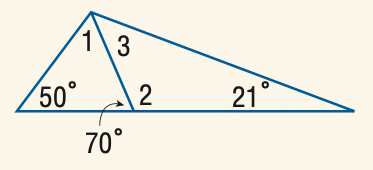Answer the mathemtical geometry problem and directly provide the correct option letter.
Question: Find the measure of \angle 2.
Choices: A: 110 B: 120 C: 130 D: 140 A 